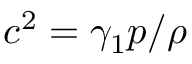<formula> <loc_0><loc_0><loc_500><loc_500>c ^ { 2 } = \gamma _ { 1 } p / \rho</formula> 